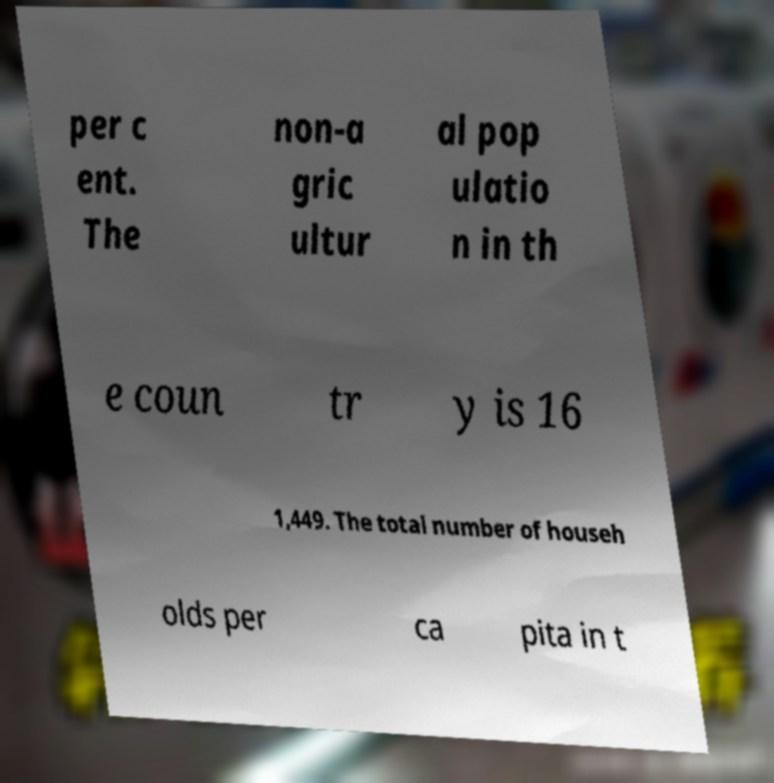Could you assist in decoding the text presented in this image and type it out clearly? per c ent. The non-a gric ultur al pop ulatio n in th e coun tr y is 16 1,449. The total number of househ olds per ca pita in t 